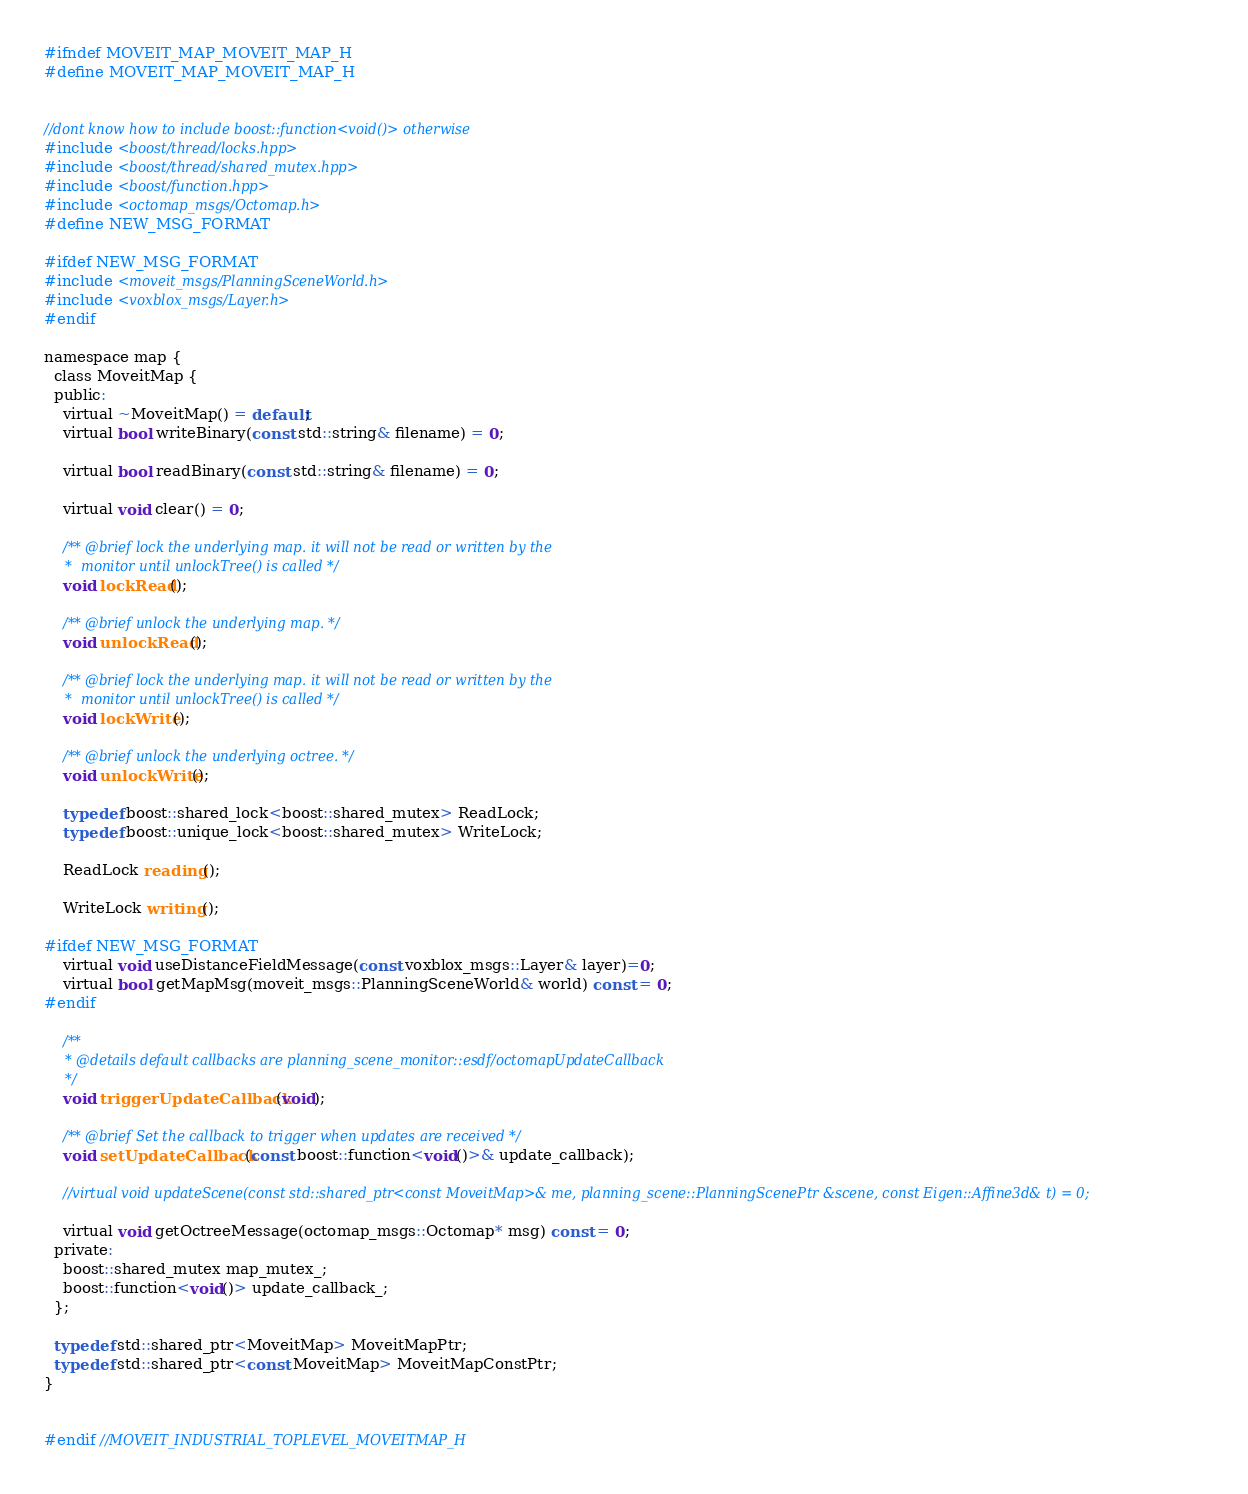<code> <loc_0><loc_0><loc_500><loc_500><_C_>#ifndef MOVEIT_MAP_MOVEIT_MAP_H
#define MOVEIT_MAP_MOVEIT_MAP_H


//dont know how to include boost::function<void()> otherwise
#include <boost/thread/locks.hpp>
#include <boost/thread/shared_mutex.hpp>
#include <boost/function.hpp>
#include <octomap_msgs/Octomap.h>
#define NEW_MSG_FORMAT

#ifdef NEW_MSG_FORMAT
#include <moveit_msgs/PlanningSceneWorld.h>
#include <voxblox_msgs/Layer.h>
#endif

namespace map {
  class MoveitMap {
  public:
    virtual ~MoveitMap() = default;
    virtual bool writeBinary(const std::string& filename) = 0;

    virtual bool readBinary(const std::string& filename) = 0;

    virtual void clear() = 0;

    /** @brief lock the underlying map. it will not be read or written by the
     *  monitor until unlockTree() is called */
    void lockRead();

    /** @brief unlock the underlying map. */
    void unlockRead();

    /** @brief lock the underlying map. it will not be read or written by the
     *  monitor until unlockTree() is called */
    void lockWrite();

    /** @brief unlock the underlying octree. */
    void unlockWrite();

    typedef boost::shared_lock<boost::shared_mutex> ReadLock;
    typedef boost::unique_lock<boost::shared_mutex> WriteLock;

    ReadLock reading();

    WriteLock writing();

#ifdef NEW_MSG_FORMAT
    virtual void useDistanceFieldMessage(const voxblox_msgs::Layer& layer)=0;
    virtual bool getMapMsg(moveit_msgs::PlanningSceneWorld& world) const = 0;
#endif

    /**
     * @details default callbacks are planning_scene_monitor::esdf/octomapUpdateCallback
     */
    void triggerUpdateCallback(void);

    /** @brief Set the callback to trigger when updates are received */
    void setUpdateCallback(const boost::function<void()>& update_callback);

    //virtual void updateScene(const std::shared_ptr<const MoveitMap>& me, planning_scene::PlanningScenePtr &scene, const Eigen::Affine3d& t) = 0;

    virtual void getOctreeMessage(octomap_msgs::Octomap* msg) const = 0;
  private:
    boost::shared_mutex map_mutex_;
    boost::function<void()> update_callback_;
  };

  typedef std::shared_ptr<MoveitMap> MoveitMapPtr;
  typedef std::shared_ptr<const MoveitMap> MoveitMapConstPtr;
}


#endif //MOVEIT_INDUSTRIAL_TOPLEVEL_MOVEITMAP_H
</code> 